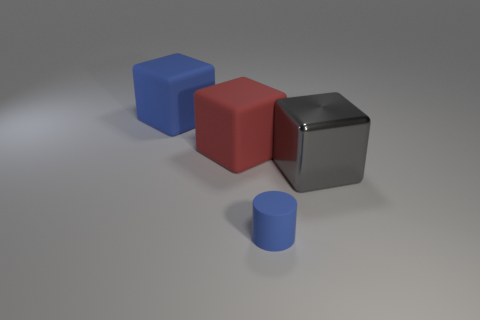There is a big cube that is the same color as the rubber cylinder; what material is it?
Provide a succinct answer. Rubber. What number of big gray metallic things are there?
Offer a very short reply. 1. There is a gray thing; is it the same shape as the blue rubber object behind the small blue thing?
Your response must be concise. Yes. What number of things are either yellow matte objects or things that are right of the blue matte cube?
Give a very brief answer. 3. What is the material of the red object that is the same shape as the big gray metal object?
Make the answer very short. Rubber. Does the rubber object behind the big red block have the same shape as the tiny matte thing?
Your answer should be compact. No. Is there anything else that has the same size as the blue rubber cylinder?
Keep it short and to the point. No. Are there fewer big blue matte objects that are right of the big gray metal thing than big red rubber objects that are left of the tiny blue rubber cylinder?
Provide a succinct answer. Yes. How many other things are the same shape as the large shiny thing?
Provide a succinct answer. 2. What size is the blue rubber thing in front of the large rubber object that is to the left of the red matte cube that is behind the blue cylinder?
Make the answer very short. Small. 